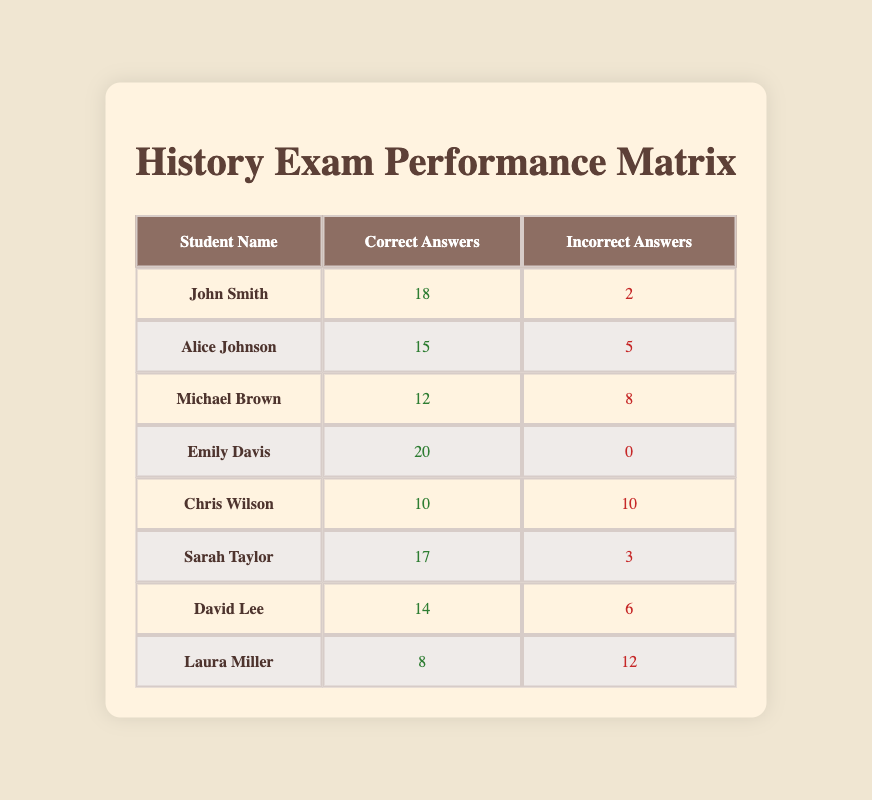What is the total number of correct answers given by all students? To find the total number of correct answers, we sum the correct answers of all the students: 18 + 15 + 12 + 20 + 10 + 17 + 14 + 8 = 114.
Answer: 114 Who scored the highest number of correct answers? To identify the student with the highest correct answers, we compare each student's correct answers. Emily Davis has 20 correct answers, which is the maximum among all.
Answer: Emily Davis Is it true that Chris Wilson had more incorrect answers than correct answers? Chris Wilson had 10 correct answers and 10 incorrect answers. Since he had equal numbers of correct and incorrect answers, the statement is false.
Answer: False What is the average number of incorrect answers among all students? To compute the average, we sum all the incorrect answers: 2 + 5 + 8 + 0 + 10 + 3 + 6 + 12 = 46. There are 8 students, so the average is 46 / 8 = 5.75.
Answer: 5.75 How many students scored more than 15 correct answers? By checking each student's correct answers, John Smith (18), Alice Johnson (15), and Emily Davis (20) scored more than 15. Counting these gives us three students.
Answer: 3 What is the difference between the highest and lowest number of incorrect answers? The maximum number of incorrect answers is 12 (Laura Miller), and the minimum is 0 (Emily Davis). The difference is 12 - 0 = 12.
Answer: 12 Which student had the least performance based on correct answers? By comparing the correct answers, Laura Miller had 8 correct answers, which is the lowest among the students.
Answer: Laura Miller How many total students answered less than 15 questions correctly? The students with less than 15 correct answers are Michael Brown (12), Chris Wilson (10), David Lee (14), and Laura Miller (8). Thus, there are four students.
Answer: 4 